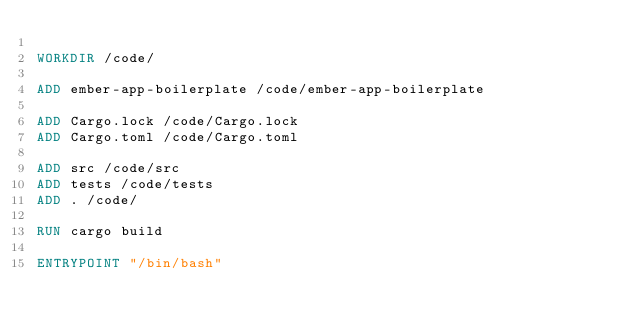Convert code to text. <code><loc_0><loc_0><loc_500><loc_500><_Dockerfile_>
WORKDIR /code/

ADD ember-app-boilerplate /code/ember-app-boilerplate

ADD Cargo.lock /code/Cargo.lock
ADD Cargo.toml /code/Cargo.toml

ADD src /code/src
ADD tests /code/tests
ADD . /code/

RUN cargo build

ENTRYPOINT "/bin/bash"
</code> 